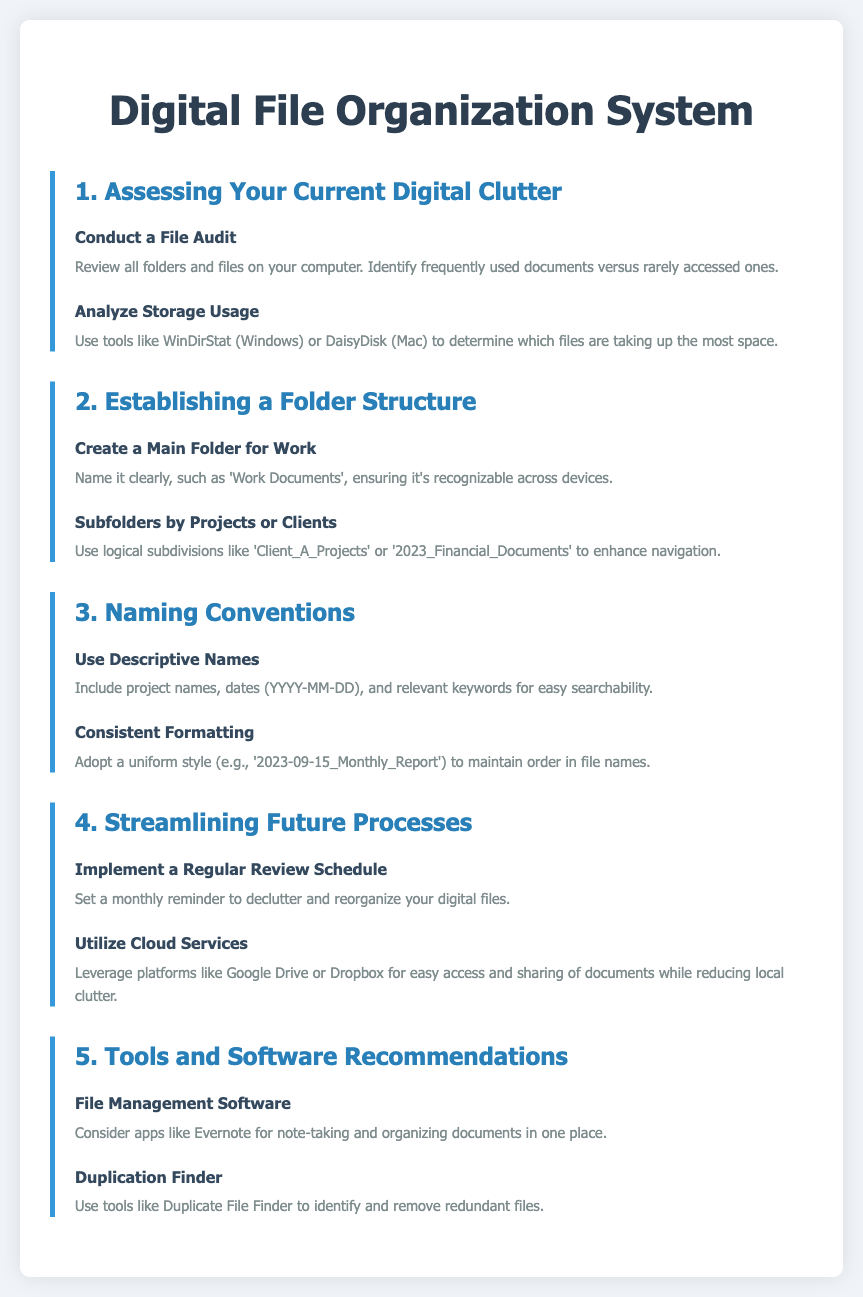What is the title of the document? The title of the document is displayed prominently at the top, indicating the main subject of the content.
Answer: Digital File Organization System How many sections are in the document? The document contains multiple sections, each addressing different aspects of digital file organization.
Answer: 5 What should you do to assess your current digital clutter? The document recommends conducting a specific activity to evaluate the existing file situation on your device.
Answer: Conduct a File Audit What platform is suggested for cloud services? The document mentions specific platforms for easy document access and sharing, reducing local clutter.
Answer: Google Drive What is the naming convention format suggested for files? The document advises a specific format in naming files, providing an example of how to structure the name.
Answer: YYYY-MM-DD What type of software is recommended for file management? The document suggests a category of software designed to help in organizing and taking notes.
Answer: Evernote What is the purpose of a regular review schedule? The document specifies a reason for setting this schedule related to file management and organization practices.
Answer: To declutter and reorganize your digital files Which tool helps identify redundant files? The document mentions a type of tool specifically designed to tackle duplicate files on your system.
Answer: Duplicate File Finder 